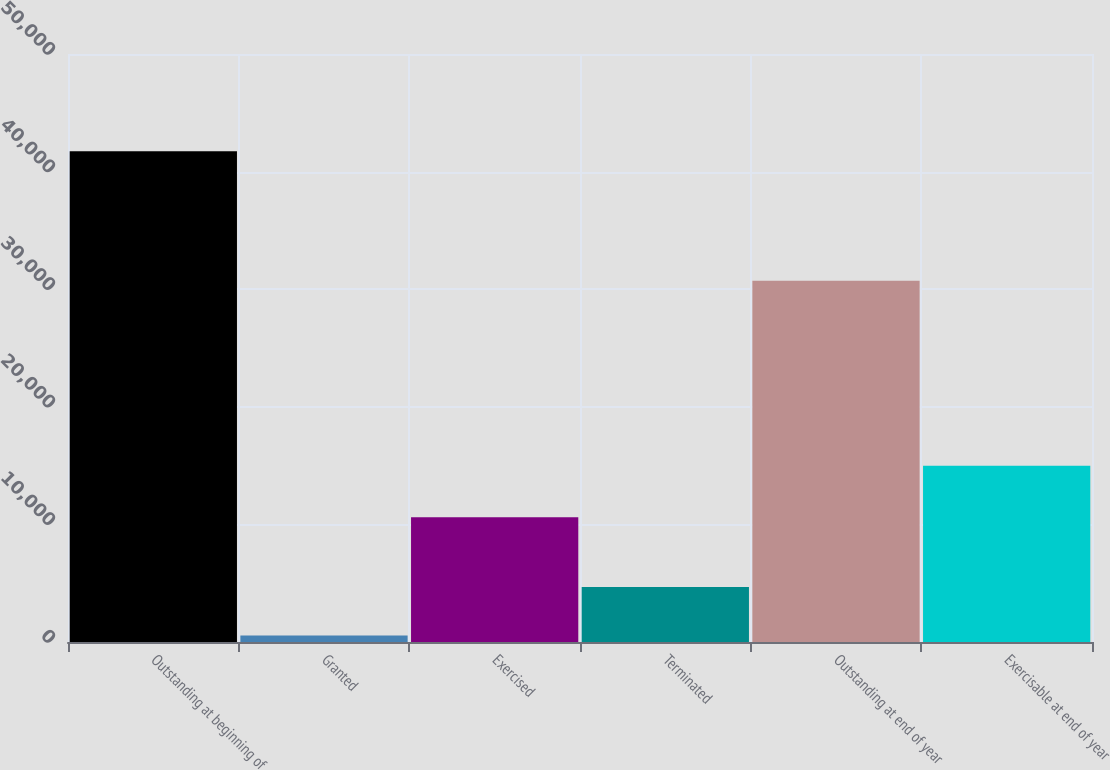<chart> <loc_0><loc_0><loc_500><loc_500><bar_chart><fcel>Outstanding at beginning of<fcel>Granted<fcel>Exercised<fcel>Terminated<fcel>Outstanding at end of year<fcel>Exercisable at end of year<nl><fcel>41735<fcel>551<fcel>10612<fcel>4669.4<fcel>30728<fcel>14979<nl></chart> 